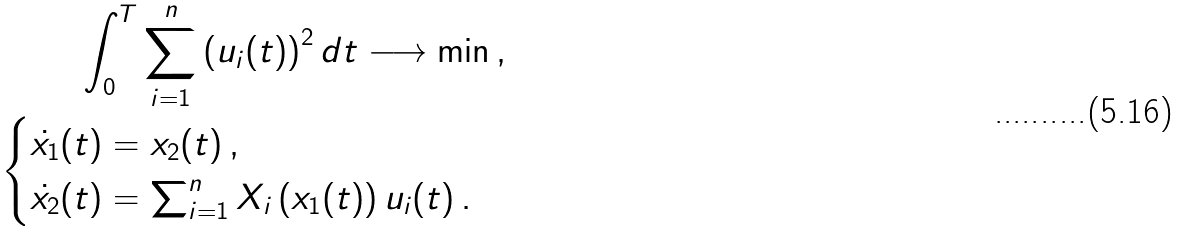Convert formula to latex. <formula><loc_0><loc_0><loc_500><loc_500>\int _ { 0 } ^ { T } \sum _ { i = 1 } ^ { n } \left ( u _ { i } ( t ) \right ) ^ { 2 } d t \longrightarrow \min \, , \\ \begin{cases} \dot { x _ { 1 } } ( t ) = x _ { 2 } ( t ) \, , \\ \dot { x _ { 2 } } ( t ) = \sum _ { i = 1 } ^ { n } X _ { i } \left ( x _ { 1 } ( t ) \right ) u _ { i } ( t ) \, . \end{cases}</formula> 